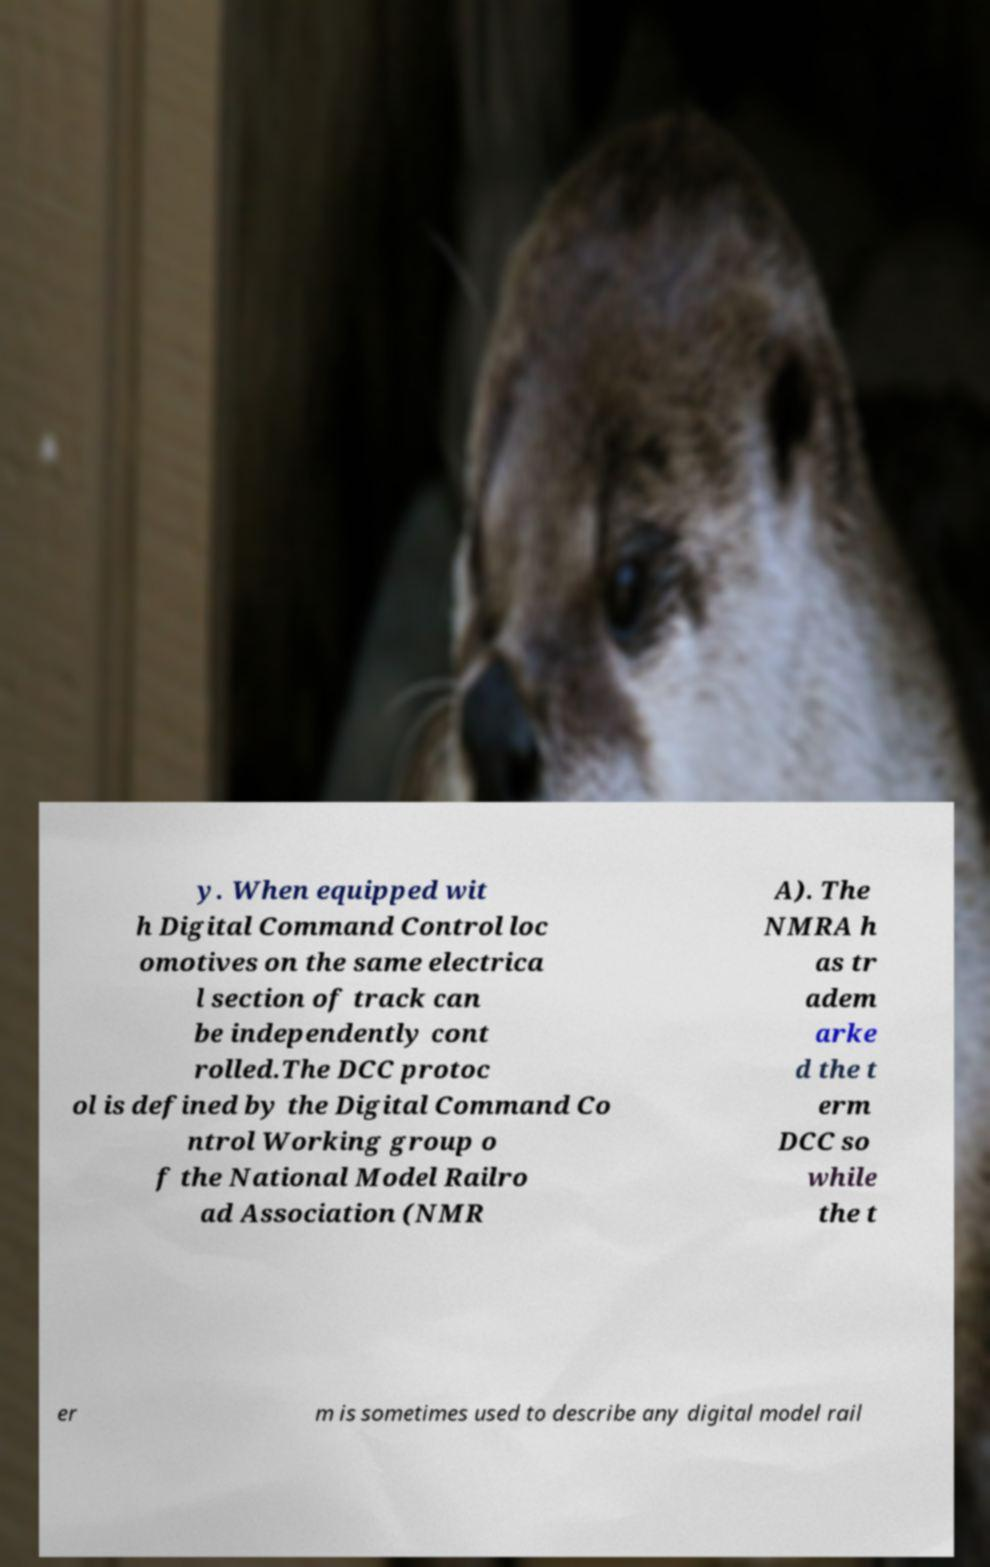Please identify and transcribe the text found in this image. y. When equipped wit h Digital Command Control loc omotives on the same electrica l section of track can be independently cont rolled.The DCC protoc ol is defined by the Digital Command Co ntrol Working group o f the National Model Railro ad Association (NMR A). The NMRA h as tr adem arke d the t erm DCC so while the t er m is sometimes used to describe any digital model rail 